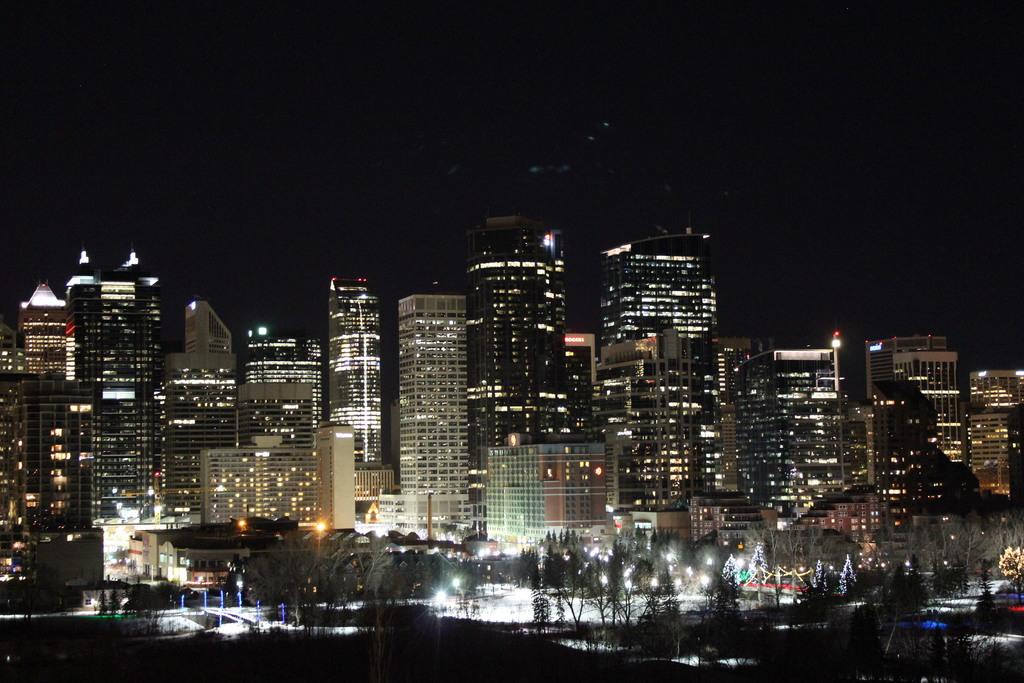What is located in the center of the image? There are buildings in the center of the image. What type of natural elements can be seen in the image? There are trees in the image. What structures are present in the image? There are poles in the image. What can be used for illumination in the image? There are lights in the image. What natural feature is visible in the image? There is water visible in the image. What is visible at the top of the image? The sky is visible at the top of the image. What type of soap is being used to clean the substance in the image? There is no soap or substance present in the image; it features buildings, trees, poles, lights, water, and the sky. What type of sleet can be seen falling in the image? There is no sleet present in the image; it features buildings, trees, poles, lights, water, and the sky. 